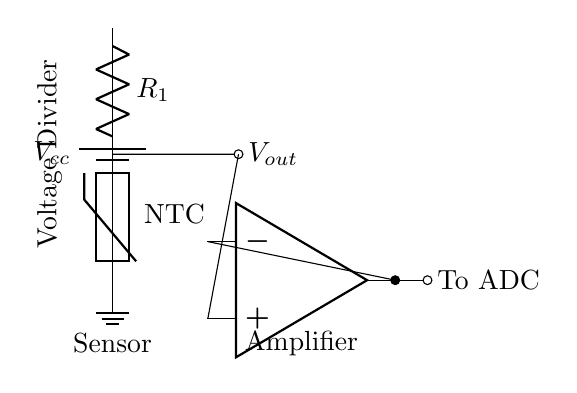What component is connected to the power supply? The component connected to the power supply in the diagram is a resistor represented as R1, which forms part of a voltage divider circuit.
Answer: Resistor What type of thermistor is used in this circuit? The circuit indicates that the thermistor used is an NTC thermistor, as labeled in the diagram. NTC stands for Negative Temperature Coefficient, which means its resistance decreases with an increase in temperature.
Answer: NTC What is the function of the operational amplifier in this circuit? The operational amplifier amplifies the voltage output from the thermistor and the resistor, making it suitable for further processing or digital conversion by the ADC. The op-amp takes in the voltage from the voltage divider and produces a larger output voltage.
Answer: Amplification What is the role of Vout in the circuit? Vout is the output voltage from the voltage divider created by the resistor and thermistor. It represents the sensed temperature and is critical for scaling the signal for the amplifier.
Answer: Sensed temperature What happens as the temperature increases in this circuit? As the temperature increases, the resistance of the NTC thermistor decreases, which results in a lower voltage output at Vout. This change in voltage is what is detected and measured to identify an increase in body temperature or fever.
Answer: Voltage decreases Which part of the circuit does the output connect to? The output from the operational amplifier connects to the ADC (Analog-to-Digital Converter) for digital processing and reading of the temperature measurement. This connection allows the analog voltage signal to be converted into a digital format for further analysis.
Answer: To ADC 